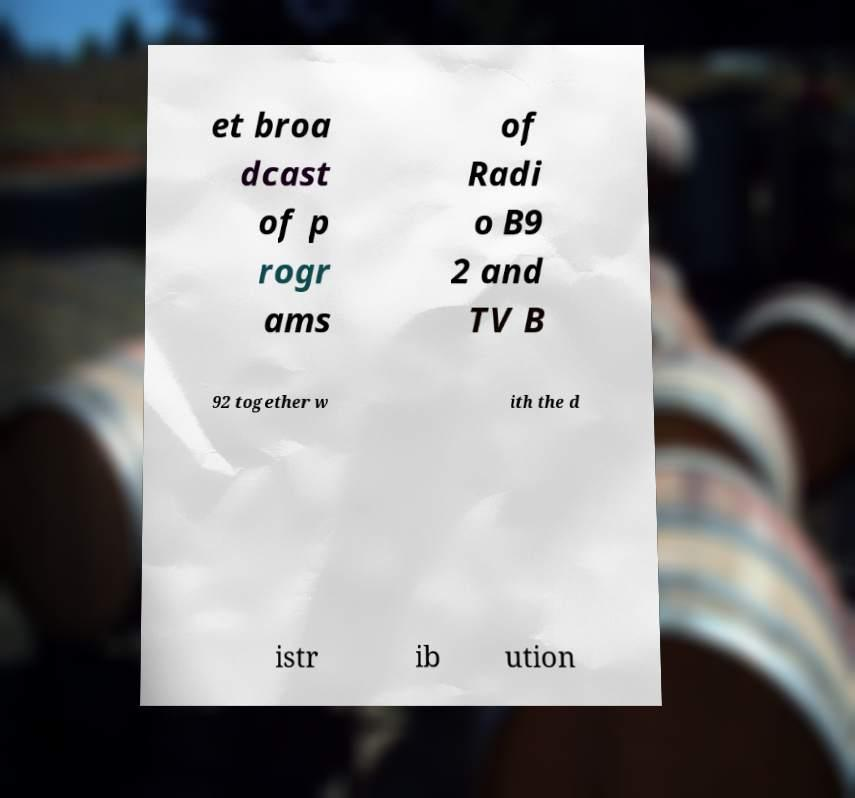What messages or text are displayed in this image? I need them in a readable, typed format. et broa dcast of p rogr ams of Radi o B9 2 and TV B 92 together w ith the d istr ib ution 